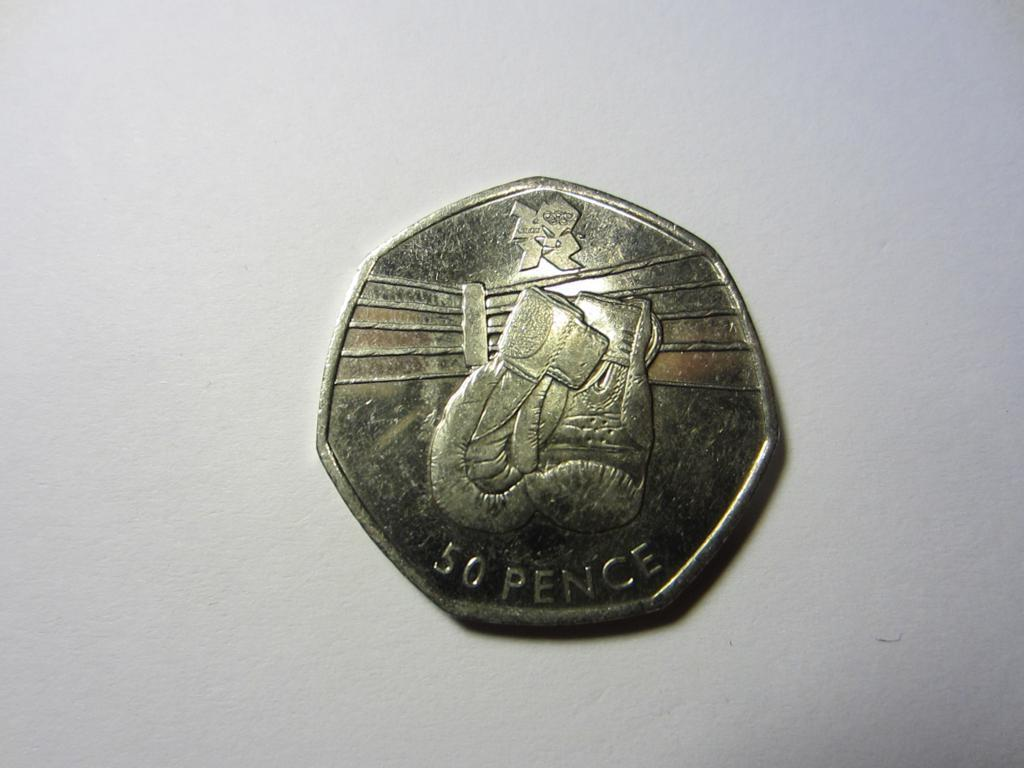Provide a one-sentence caption for the provided image. A gold coin that is worth 50 pence is on the table. 